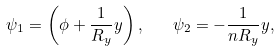<formula> <loc_0><loc_0><loc_500><loc_500>\psi _ { 1 } = \left ( \phi + \frac { 1 } { R _ { y } } y \right ) , \quad \psi _ { 2 } = - \frac { 1 } { n R _ { y } } y ,</formula> 